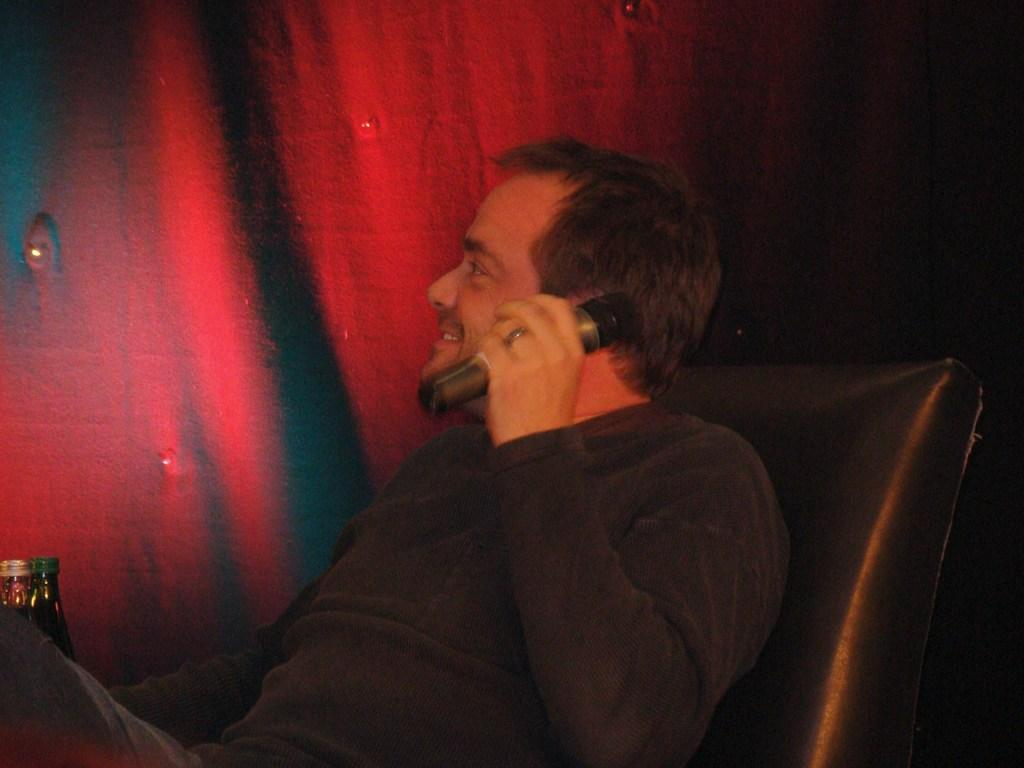What is the person in the image doing? The person is sitting on a chair and holding a mic. What is the person's facial expression in the image? The person is smiling. What can be seen on the left side of the image? There are two bottles on the left side of the image. What is visible in the background of the image? There is a red curtain in the background of the image. How many lizards are crawling on the person's leg in the image? There are no lizards present in the image, and the person's leg is not visible. 